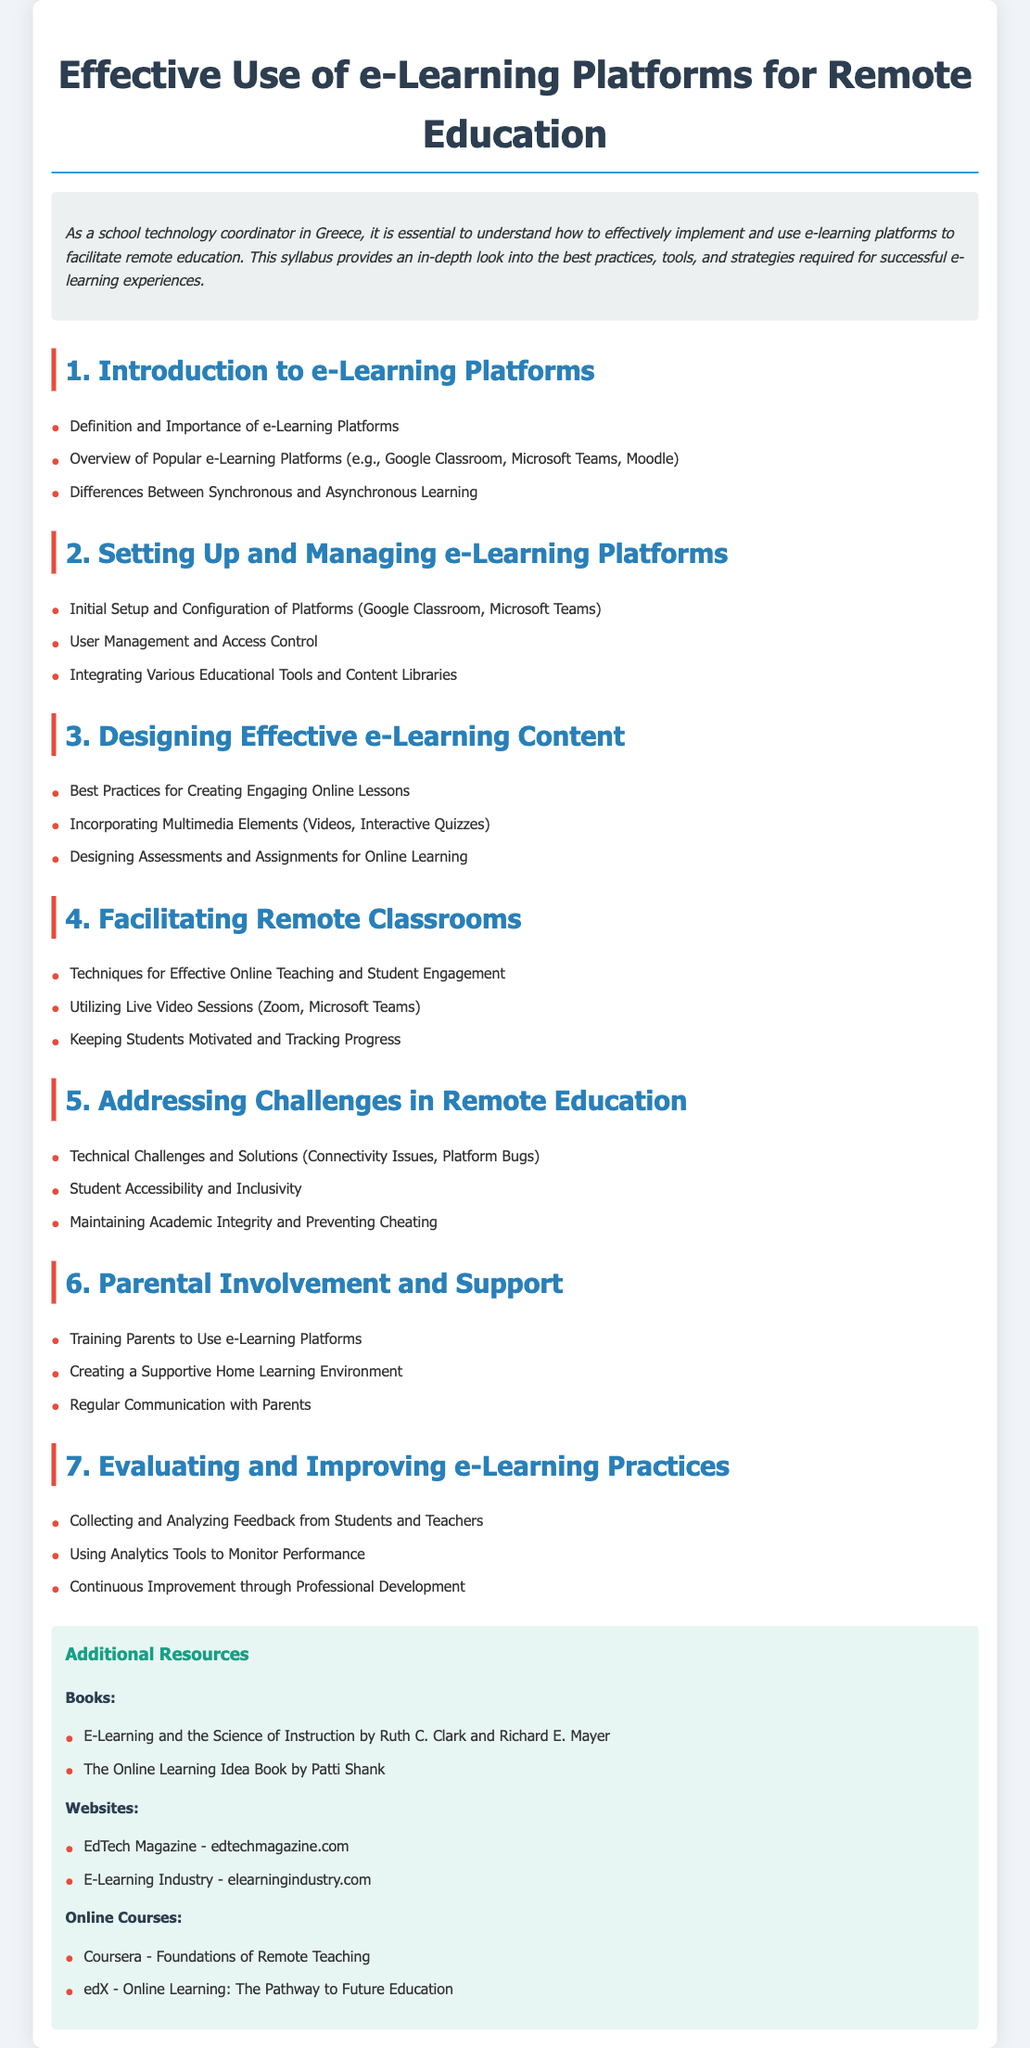What is the title of the syllabus? The title of the syllabus is mentioned at the top of the document, which indicates the topic of study.
Answer: Effective Use of e-Learning Platforms for Remote Education How many main sections are there in the syllabus? The main sections are numbered in the document, providing a clear structure.
Answer: 7 Name one popular e-learning platform mentioned in the document. Popular e-learning platforms are listed in the introduction section.
Answer: Google Classroom What is a technique for keeping students motivated as per the syllabus? Techniques for student motivation are listed under the section for facilitating remote classrooms.
Answer: Keeping Students Motivated What is the first resource type listed in the additional resources section? The resource types are clearly categorized in the additional resources section of the document.
Answer: Books Which online course is recommended for foundations of remote teaching? The document lists specific online courses under additional resources.
Answer: Foundations of Remote Teaching What is emphasized in the section about addressing challenges in remote education? This section outlines areas of concern in remote education and offers insights.
Answer: Technical Challenges and Solutions How can student and teacher feedback be utilized according to the syllabus? The syllabus mentions the importance of feedback for improving practices in e-learning.
Answer: Collecting and Analyzing Feedback 